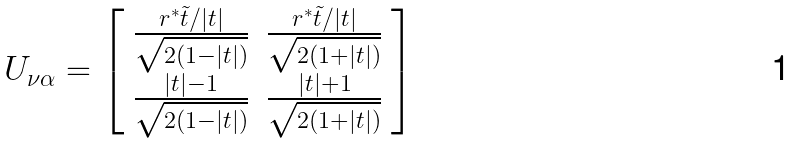Convert formula to latex. <formula><loc_0><loc_0><loc_500><loc_500>U _ { \nu \alpha } = \left [ \begin{array} { c c } \frac { r ^ { * } \tilde { t } / | t | } { \sqrt { 2 ( 1 - | t | ) } } & \frac { r ^ { * } \tilde { t } / | t | } { \sqrt { 2 ( 1 + | t | ) } } \\ \frac { | t | - 1 } { \sqrt { 2 ( 1 - | t | ) } } & \frac { | t | + 1 } { \sqrt { 2 ( 1 + | t | ) } } \end{array} \right ]</formula> 